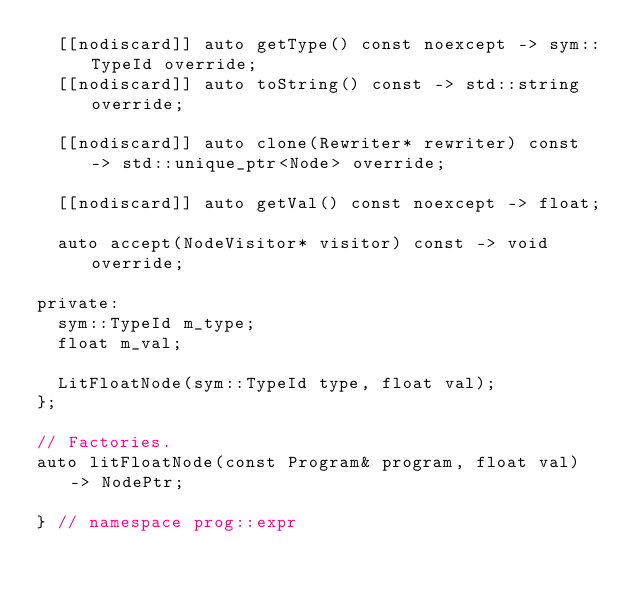<code> <loc_0><loc_0><loc_500><loc_500><_C++_>  [[nodiscard]] auto getType() const noexcept -> sym::TypeId override;
  [[nodiscard]] auto toString() const -> std::string override;

  [[nodiscard]] auto clone(Rewriter* rewriter) const -> std::unique_ptr<Node> override;

  [[nodiscard]] auto getVal() const noexcept -> float;

  auto accept(NodeVisitor* visitor) const -> void override;

private:
  sym::TypeId m_type;
  float m_val;

  LitFloatNode(sym::TypeId type, float val);
};

// Factories.
auto litFloatNode(const Program& program, float val) -> NodePtr;

} // namespace prog::expr
</code> 